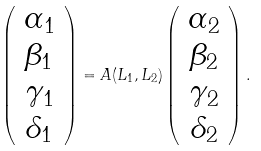<formula> <loc_0><loc_0><loc_500><loc_500>\left ( \begin{array} { c c c c } \alpha _ { 1 } \\ \beta _ { 1 } \\ \gamma _ { 1 } \\ \delta _ { 1 } \\ \end{array} \right ) = A ( L _ { 1 } , L _ { 2 } ) \left ( \begin{array} { c c c c } \alpha _ { 2 } \\ \beta _ { 2 } \\ \gamma _ { 2 } \\ \delta _ { 2 } \\ \end{array} \right ) .</formula> 